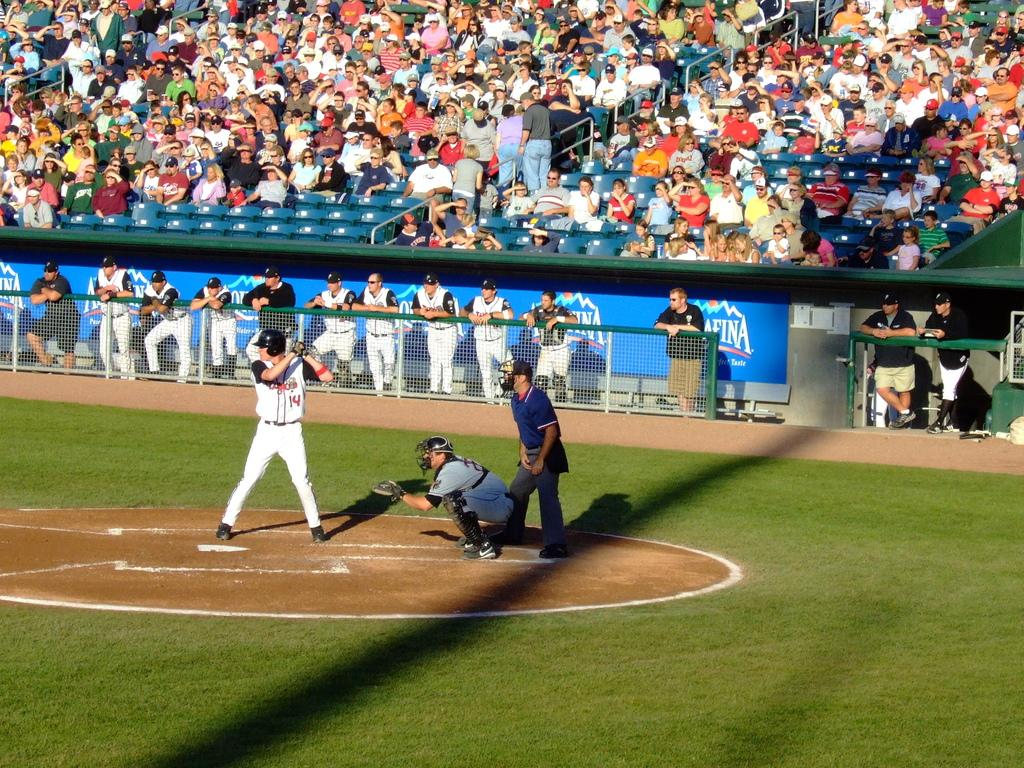<image>
Provide a brief description of the given image. Player number 14, with white suit is waiting for the ball to be shot. 